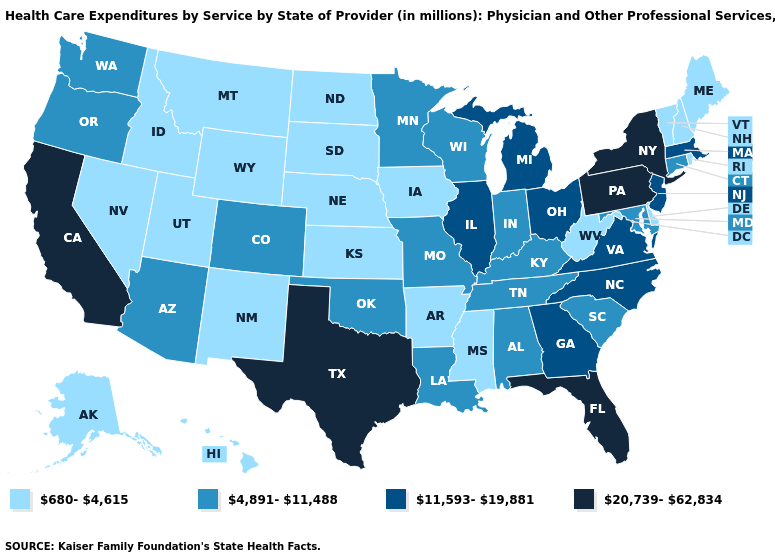Among the states that border Nevada , does Arizona have the lowest value?
Keep it brief. No. Does Delaware have the same value as Louisiana?
Give a very brief answer. No. Does Maine have a higher value than Hawaii?
Answer briefly. No. Name the states that have a value in the range 20,739-62,834?
Quick response, please. California, Florida, New York, Pennsylvania, Texas. Does the first symbol in the legend represent the smallest category?
Quick response, please. Yes. What is the value of New York?
Short answer required. 20,739-62,834. What is the lowest value in the MidWest?
Be succinct. 680-4,615. Does Illinois have the lowest value in the MidWest?
Concise answer only. No. What is the value of Wyoming?
Keep it brief. 680-4,615. What is the highest value in the Northeast ?
Answer briefly. 20,739-62,834. What is the value of Oklahoma?
Quick response, please. 4,891-11,488. What is the lowest value in the MidWest?
Short answer required. 680-4,615. Does the map have missing data?
Short answer required. No. Name the states that have a value in the range 4,891-11,488?
Answer briefly. Alabama, Arizona, Colorado, Connecticut, Indiana, Kentucky, Louisiana, Maryland, Minnesota, Missouri, Oklahoma, Oregon, South Carolina, Tennessee, Washington, Wisconsin. What is the lowest value in the USA?
Answer briefly. 680-4,615. 